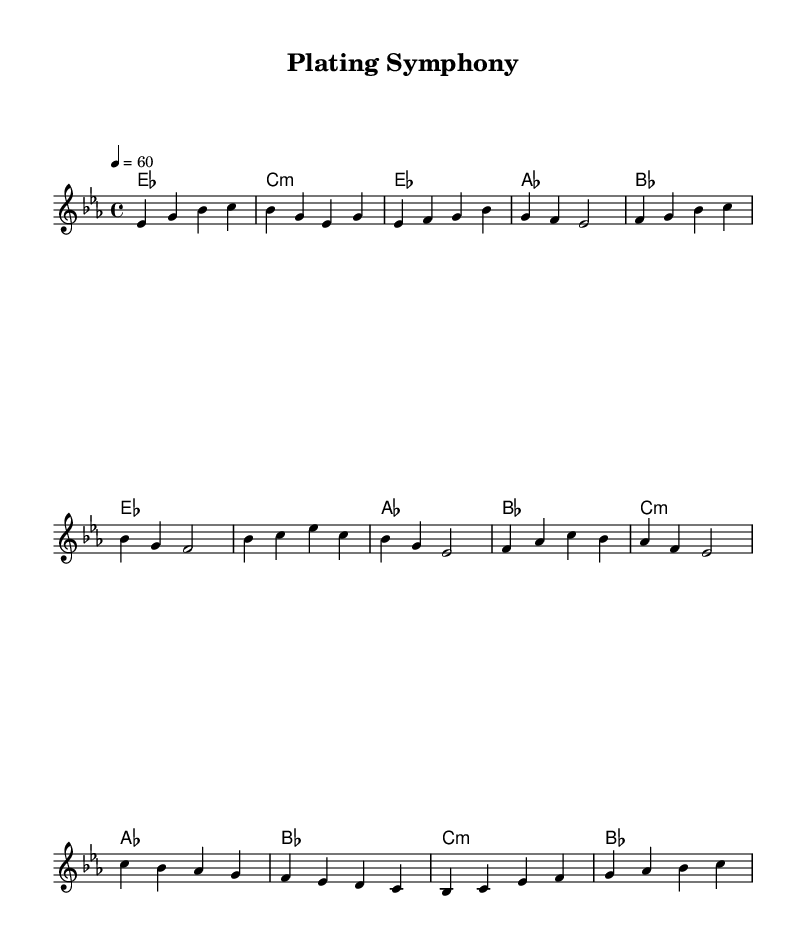What is the key signature of this music? The key signature is E flat major, which includes three flat notes: B flat, E flat, and A flat. This can be identified by looking at the beginning of the staff where the flats are indicated.
Answer: E flat major What is the time signature of the piece? The time signature appears at the beginning of the sheet music as 4/4, which indicates four beats per measure with a quarter note receiving one beat. This is found near the key signature at the start.
Answer: 4/4 What is the tempo marking for this music? The tempo marking is indicated as 4 = 60, which shows that each quarter note is played at 60 beats per minute. This is typically found at the start of the piece above the staff.
Answer: 60 What is the first chord played in the piece? The first chord indicated in the sheet music is E flat major, as seen in the chord names under the melody line. This chord is shown at the start of the score.
Answer: E flat major How many measures are in the verse section? The verse section contains eight measures, which can be counted by examining the notation of the melody line and the format of the music that divides the sections.
Answer: Eight measures What type of soul music does this sheet represent? This piece represents smooth soul ballads, which can be inferred from the slow tempo and the lyrical quality of the melody and harmonies typical of this genre.
Answer: Smooth soul ballad 